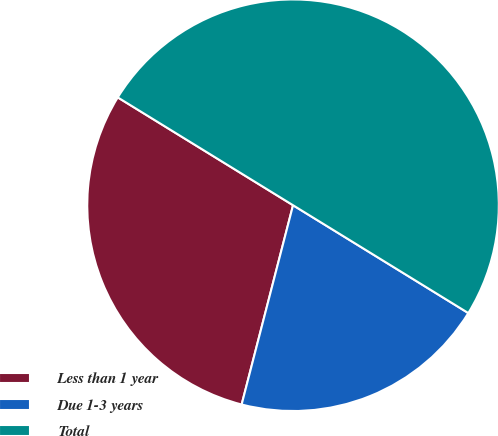Convert chart. <chart><loc_0><loc_0><loc_500><loc_500><pie_chart><fcel>Less than 1 year<fcel>Due 1-3 years<fcel>Total<nl><fcel>29.76%<fcel>20.24%<fcel>50.0%<nl></chart> 